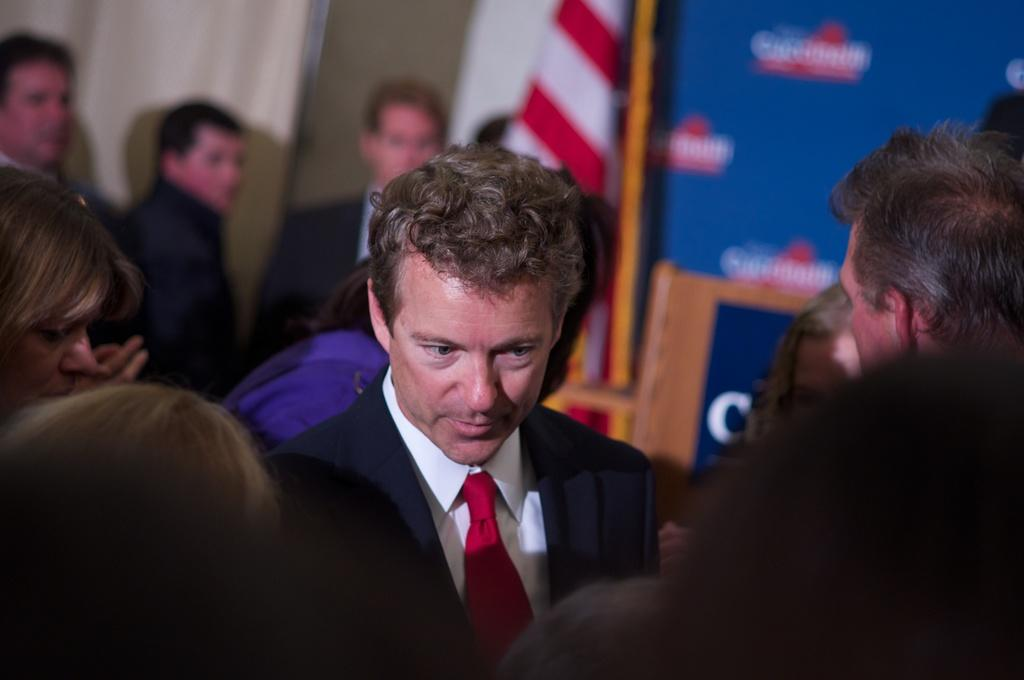What is the main subject of the image? There is a group of people in the center of the image. What can be seen in the background of the image? There is a wall, a flag, and boards in the background of the image. What type of pencil can be seen in the pocket of one of the people in the image? There is no pencil or pocket visible in the image. What is the engine used for in the image? There is no engine present in the image. 